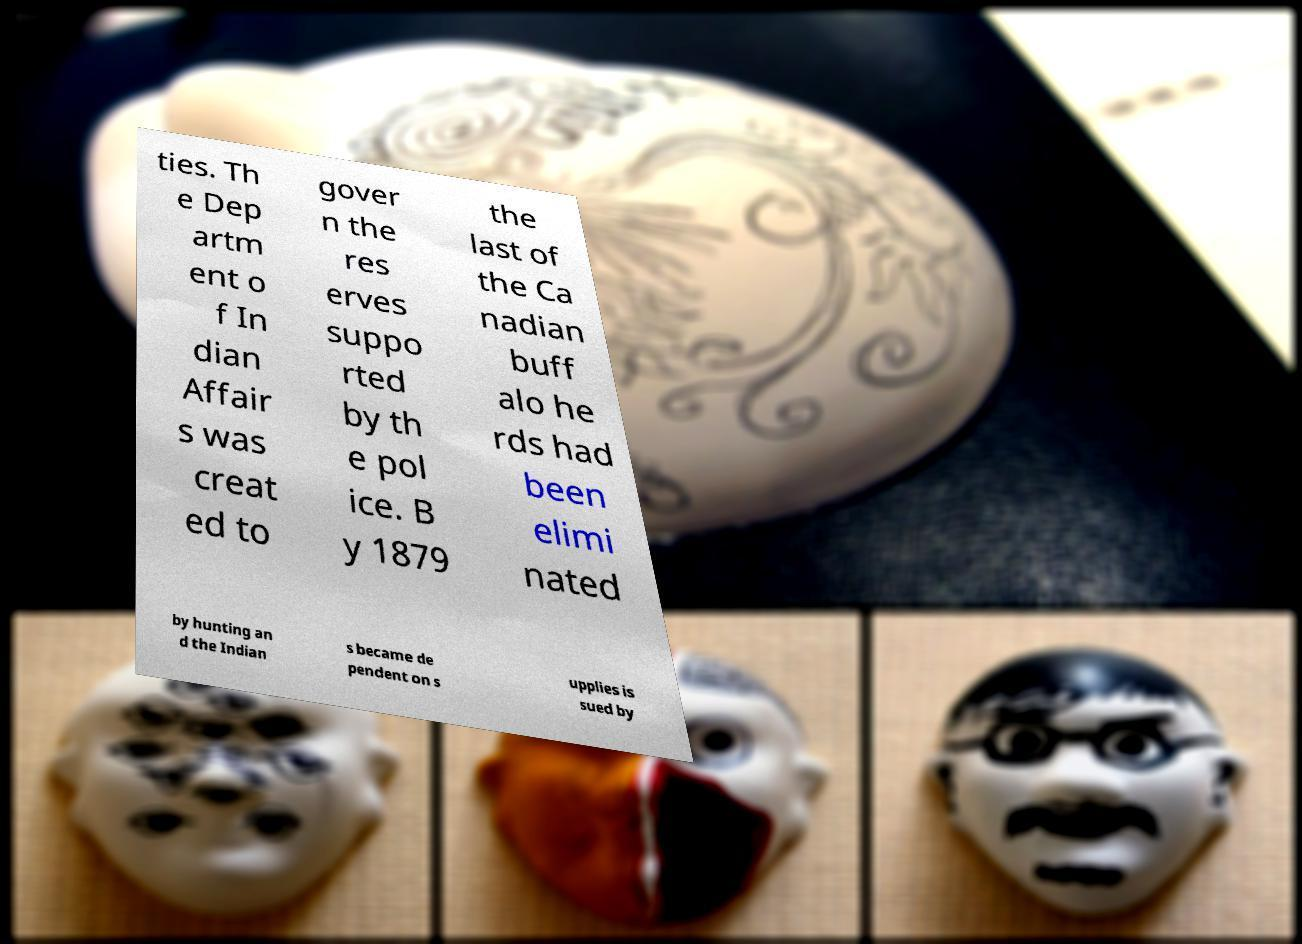What messages or text are displayed in this image? I need them in a readable, typed format. ties. Th e Dep artm ent o f In dian Affair s was creat ed to gover n the res erves suppo rted by th e pol ice. B y 1879 the last of the Ca nadian buff alo he rds had been elimi nated by hunting an d the Indian s became de pendent on s upplies is sued by 